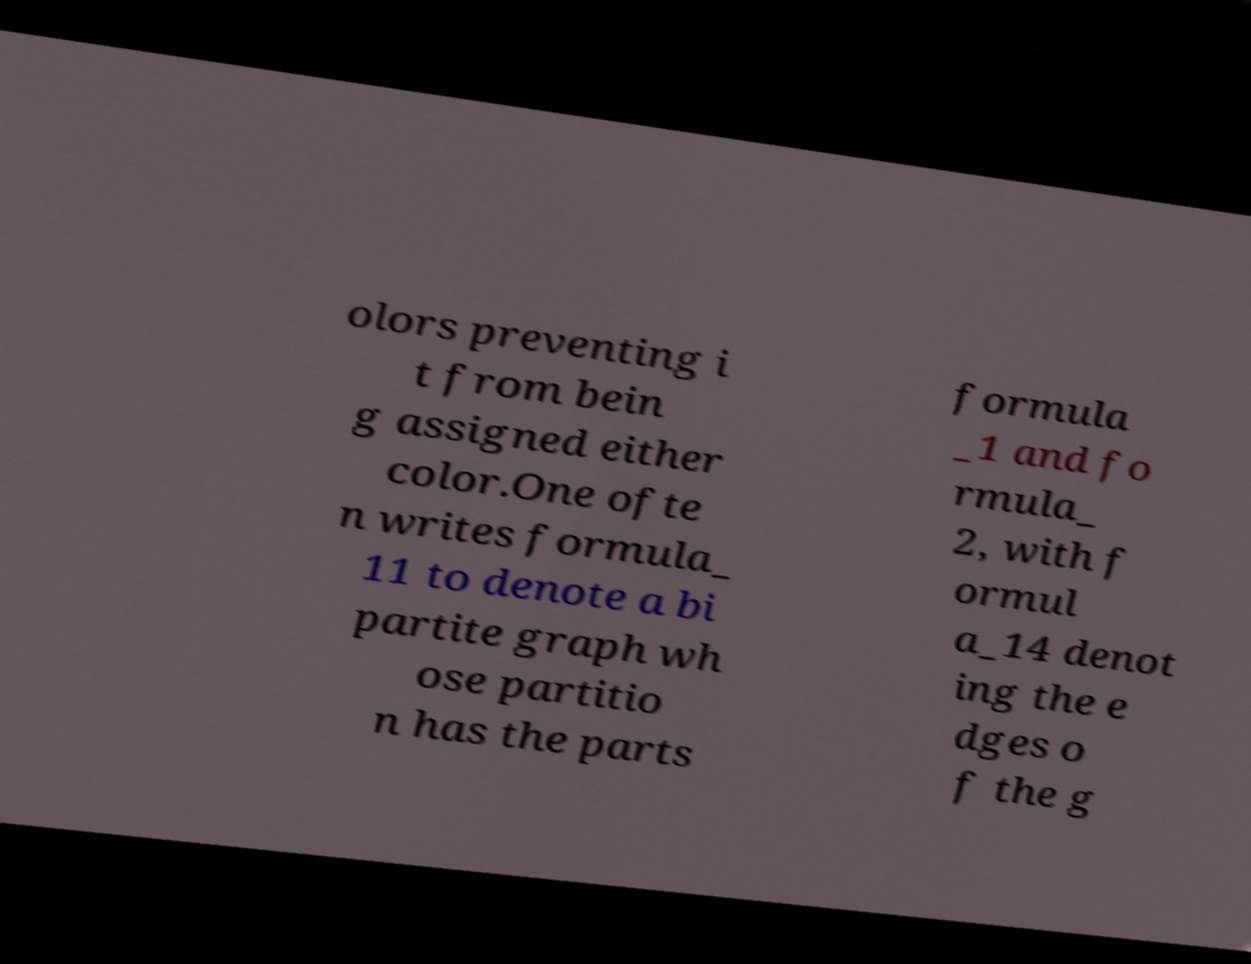Can you accurately transcribe the text from the provided image for me? olors preventing i t from bein g assigned either color.One ofte n writes formula_ 11 to denote a bi partite graph wh ose partitio n has the parts formula _1 and fo rmula_ 2, with f ormul a_14 denot ing the e dges o f the g 